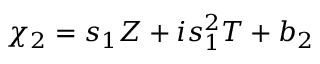<formula> <loc_0><loc_0><loc_500><loc_500>\chi _ { 2 } = s _ { 1 } Z + i s _ { 1 } ^ { 2 } T + b _ { 2 }</formula> 